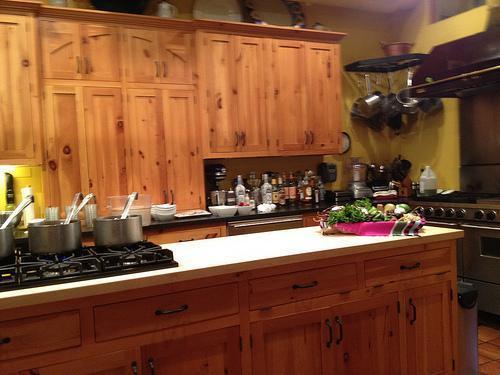How many pots are on the island?
Give a very brief answer. 3. 